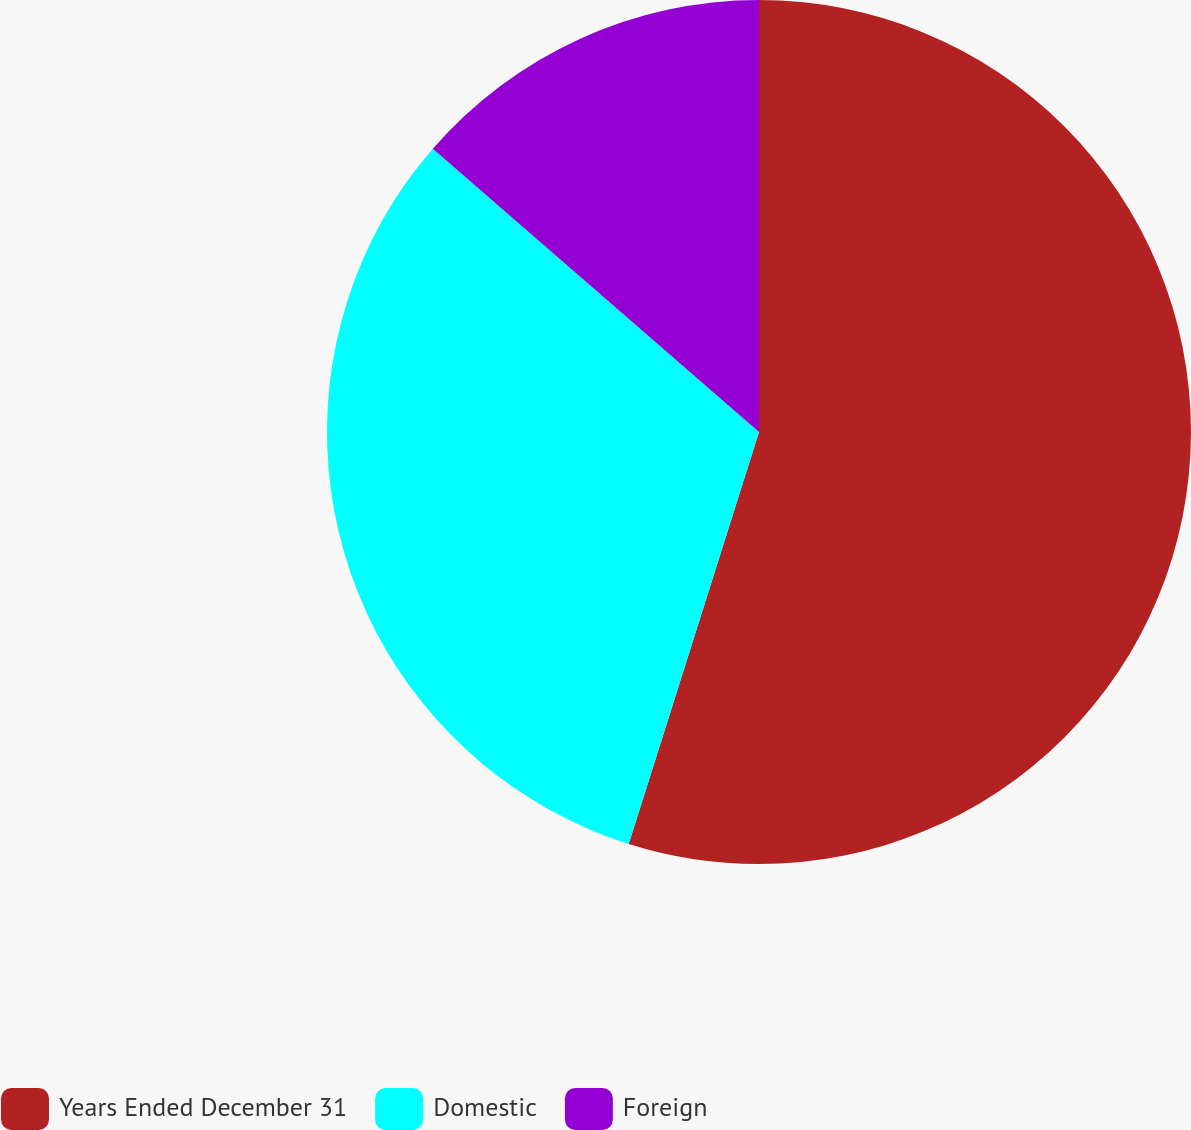Convert chart. <chart><loc_0><loc_0><loc_500><loc_500><pie_chart><fcel>Years Ended December 31<fcel>Domestic<fcel>Foreign<nl><fcel>54.87%<fcel>31.5%<fcel>13.62%<nl></chart> 